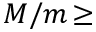<formula> <loc_0><loc_0><loc_500><loc_500>M / m \, \geq</formula> 